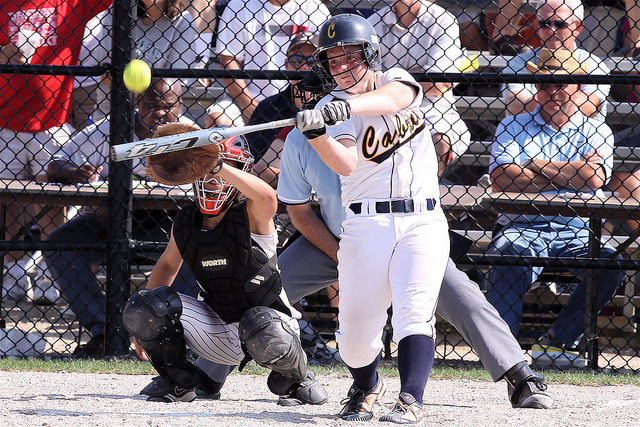Imagine you are one of the spectators in the background. Describe your experience watching this game. As a spectator, the atmosphere is electric. You are seated behind the chain-link fence, eagerly watching every play unfold. The sun is shining brightly, and the air is filled with the sounds of cheering fans and the crack of the bat. The tension is palpable, especially during crucial moments like the batter's swing depicted in the image. You can feel the excitement and anticipation in the air as you cheer on your favorite team and share the experience with fellow fans around you, creating memories that will last long after the game is over. 